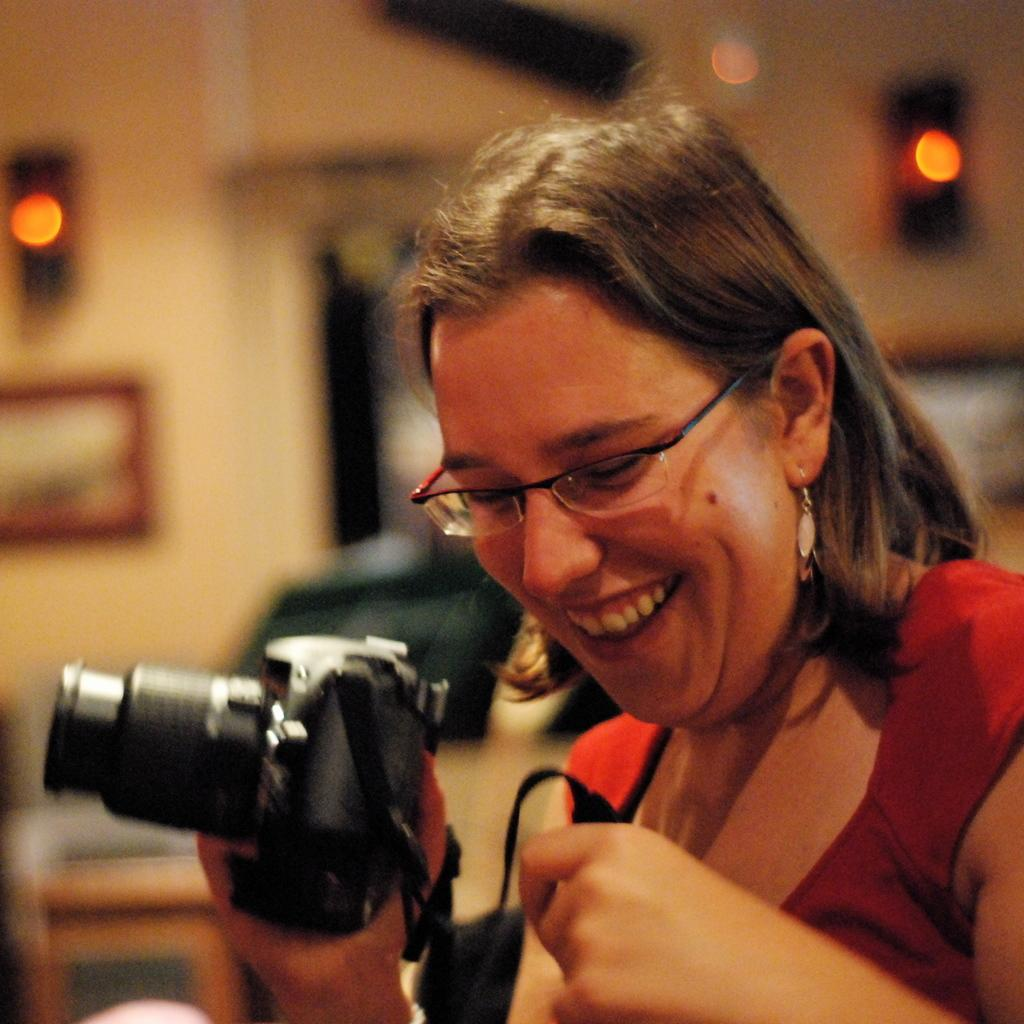Who is the main subject in the image? There is a woman in the image. What is the woman holding in the image? The woman is holding a camera. What can be seen in the background of the image? There is a wall and lights in the background of the image. Are the woman's friends wearing masks in the image? There is no mention of friends or masks in the image; it only shows a woman holding a camera with a wall and lights in the background. 